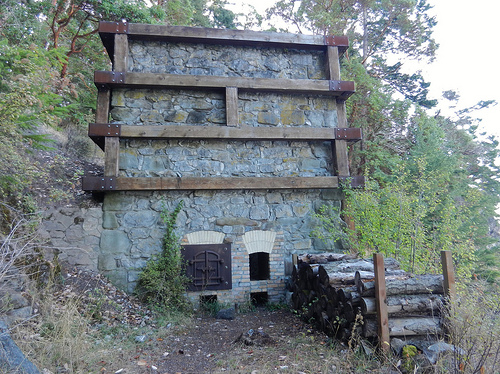<image>
Can you confirm if the structure is to the right of the wood? No. The structure is not to the right of the wood. The horizontal positioning shows a different relationship. 